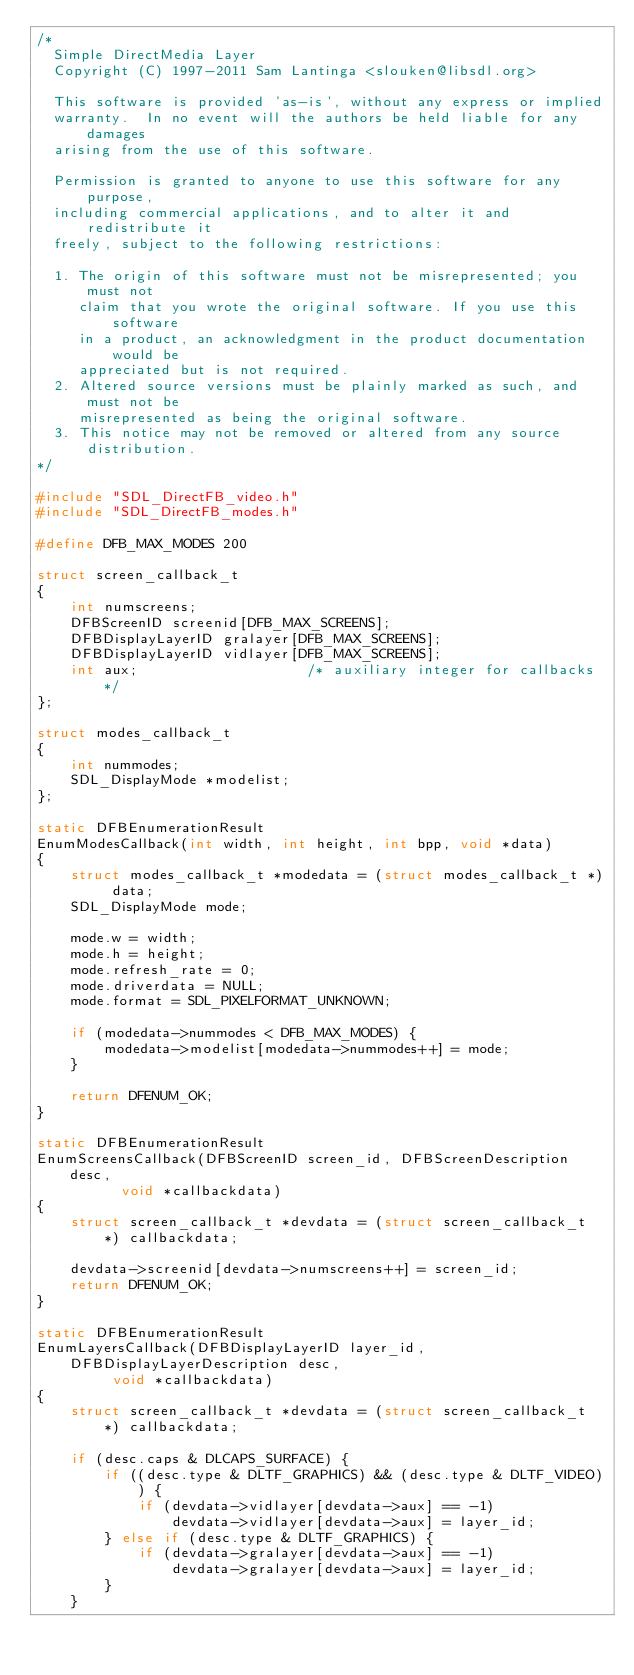<code> <loc_0><loc_0><loc_500><loc_500><_C_>/*
  Simple DirectMedia Layer
  Copyright (C) 1997-2011 Sam Lantinga <slouken@libsdl.org>

  This software is provided 'as-is', without any express or implied
  warranty.  In no event will the authors be held liable for any damages
  arising from the use of this software.

  Permission is granted to anyone to use this software for any purpose,
  including commercial applications, and to alter it and redistribute it
  freely, subject to the following restrictions:

  1. The origin of this software must not be misrepresented; you must not
     claim that you wrote the original software. If you use this software
     in a product, an acknowledgment in the product documentation would be
     appreciated but is not required.
  2. Altered source versions must be plainly marked as such, and must not be
     misrepresented as being the original software.
  3. This notice may not be removed or altered from any source distribution.
*/

#include "SDL_DirectFB_video.h"
#include "SDL_DirectFB_modes.h"

#define DFB_MAX_MODES 200

struct screen_callback_t
{
    int numscreens;
    DFBScreenID screenid[DFB_MAX_SCREENS];
    DFBDisplayLayerID gralayer[DFB_MAX_SCREENS];
    DFBDisplayLayerID vidlayer[DFB_MAX_SCREENS];
    int aux;                    /* auxiliary integer for callbacks */
};

struct modes_callback_t
{
    int nummodes;
    SDL_DisplayMode *modelist;
};

static DFBEnumerationResult
EnumModesCallback(int width, int height, int bpp, void *data)
{
    struct modes_callback_t *modedata = (struct modes_callback_t *) data;
    SDL_DisplayMode mode;

    mode.w = width;
    mode.h = height;
    mode.refresh_rate = 0;
    mode.driverdata = NULL;
    mode.format = SDL_PIXELFORMAT_UNKNOWN;

    if (modedata->nummodes < DFB_MAX_MODES) {
        modedata->modelist[modedata->nummodes++] = mode;
    }

    return DFENUM_OK;
}

static DFBEnumerationResult
EnumScreensCallback(DFBScreenID screen_id, DFBScreenDescription desc,
          void *callbackdata)
{
    struct screen_callback_t *devdata = (struct screen_callback_t *) callbackdata;

    devdata->screenid[devdata->numscreens++] = screen_id;
    return DFENUM_OK;
}

static DFBEnumerationResult
EnumLayersCallback(DFBDisplayLayerID layer_id, DFBDisplayLayerDescription desc,
         void *callbackdata)
{
    struct screen_callback_t *devdata = (struct screen_callback_t *) callbackdata;

    if (desc.caps & DLCAPS_SURFACE) {
        if ((desc.type & DLTF_GRAPHICS) && (desc.type & DLTF_VIDEO)) {
            if (devdata->vidlayer[devdata->aux] == -1)
                devdata->vidlayer[devdata->aux] = layer_id;
        } else if (desc.type & DLTF_GRAPHICS) {
            if (devdata->gralayer[devdata->aux] == -1)
                devdata->gralayer[devdata->aux] = layer_id;
        }
    }</code> 